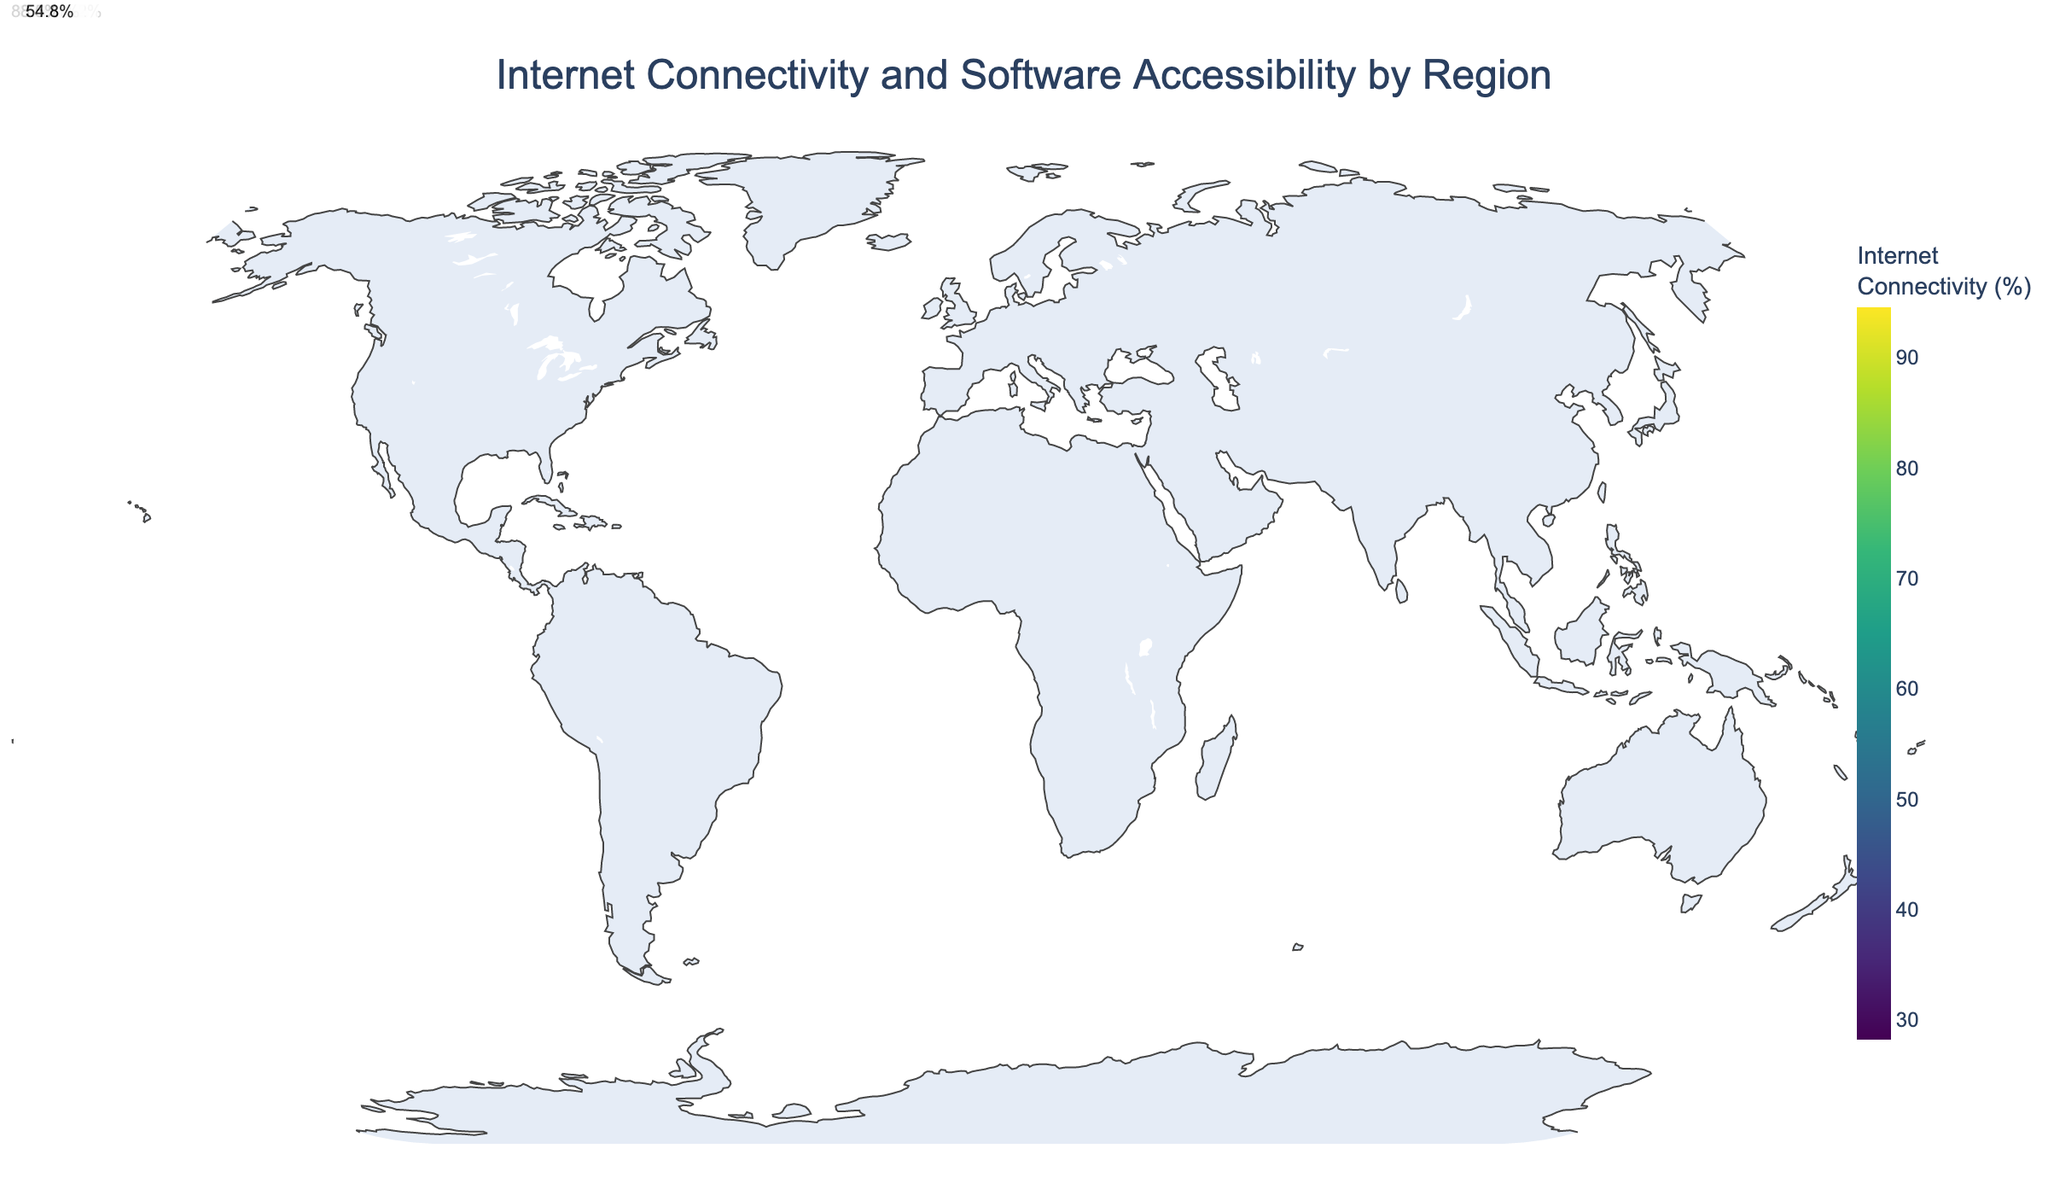Which region has the highest Internet connectivity rate? Look at the color gradient on the map; darker regions represent higher Internet connectivity rates. The title indicates the measurements are in percentages. Checking the labels, North America has the highest rate at 94.6%.
Answer: North America What are the Internet connectivity rates and software accessibility scores for the regions with the lowest and the highest connectivity rates? Identify the regions with the lowest and highest connectivity rates by finding the extremities on the color gradient legend. North America has the highest connectivity rate of 94.6% with a software accessibility score of 9.2, while Sub-Saharan Africa has the lowest connectivity rate of 28.2% with a software accessibility score of 4.1.
Answer: 94.6% with a score of 9.2 for North America, 28.2% with a score of 4.1 for Sub-Saharan Africa How does the Internet connectivity rate in Oceania compare to that in East Asia? Locate both Oceania and East Asia on the map. Oceania's connectivity rate is 88.5%, and East Asia's is 87.9%.
Answer: Oceania has a slightly higher rate than East Asia What's the average Internet connectivity rate for Western Europe and Eastern Europe? Find the connectivity rates for both regions: Western Europe is 92.3% and Eastern Europe is 82.5%. Sum these rates and divide by 2 to get the average: (92.3 + 82.5) / 2 = 87.4%.
Answer: 87.4% What region has an Internet connectivity rate closest to the global average rate (calculated as the average of all provided regions)? Calculate the global average: (94.6 + 92.3 + 82.5 + 87.9 + 69.3 + 48.4 + 76.8 + 55.2 + 28.2 + 72 + 63.9 + 88.5 + 54.8) / 13 ≈ 71.2%. Compare this average to individual region rates to find the closest value. Latin America has a rate of 72.0%, which is closest to the global average.
Answer: Latin America Which region shows a significant discrepancy between Internet connectivity rate and software accessibility score, and what are these values? Look for regions where the Internet connectivity rate and software accessibility score are notably different. South Asia stands out with an Internet connectivity rate of 48.4% and a software accessibility score of 5.2.
Answer: South Asia with 48.4% and a score of 5.2 How do Southeast Asia and Latin America compare in terms of their Internet connectivity rate and software accessibility score? Check the rates on the map: Southeast Asia has a connectivity rate of 69.3% and a score of 6.7, while Latin America has a rate of 72.0% and a score of 7.0. Latin America has slightly higher values in both metrics.
Answer: Latin America is higher in both rates What is the range of Software Accessibility Scores for the regions with Internet connectivity rates greater than 80%? Identify the regions with connectivity rates above 80%: North America, Western Europe, Eastern Europe, East Asia, and Oceania. Their scores are 9.2, 9.0, 7.8, 8.5, and 8.7, respectively. The range is from 7.8 to 9.2.
Answer: 7.8 to 9.2 Which region in the Middle East, North Africa, or Central Asia has the closest Internet connectivity rate and software accessibility score to Oceania? Compare Oceania (88.5%, 8.7) with Middle East (76.8%, 7.3), North Africa (55.2%, 5.8), and Central Asia (54.8%, 5.7). The Middle East has the closest rates and scores.
Answer: Middle East 